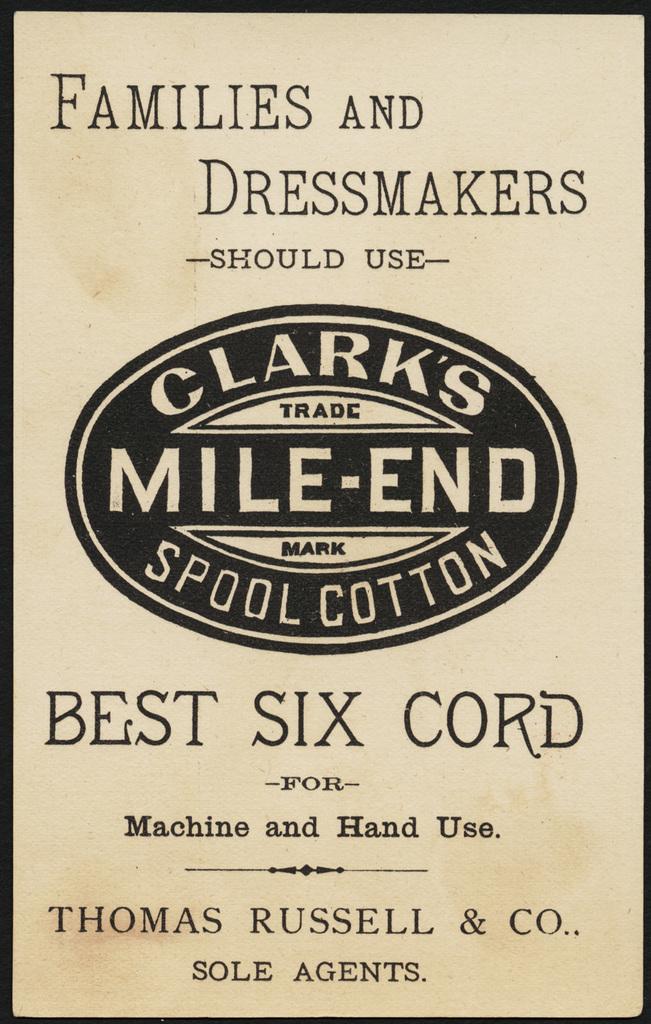What brand is being advertised on this sign?
Ensure brevity in your answer.  Clark's. Who should use the cotton, according to the sign?
Keep it short and to the point. Families and dressmakers. 